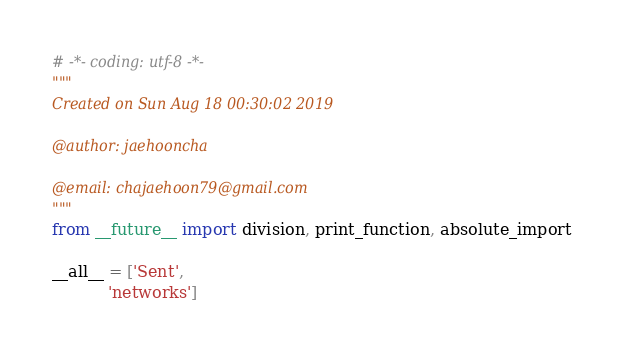Convert code to text. <code><loc_0><loc_0><loc_500><loc_500><_Python_># -*- coding: utf-8 -*-
"""
Created on Sun Aug 18 00:30:02 2019

@author: jaehooncha

@email: chajaehoon79@gmail.com
"""
from __future__ import division, print_function, absolute_import

__all__ = ['Sent',
           'networks']</code> 